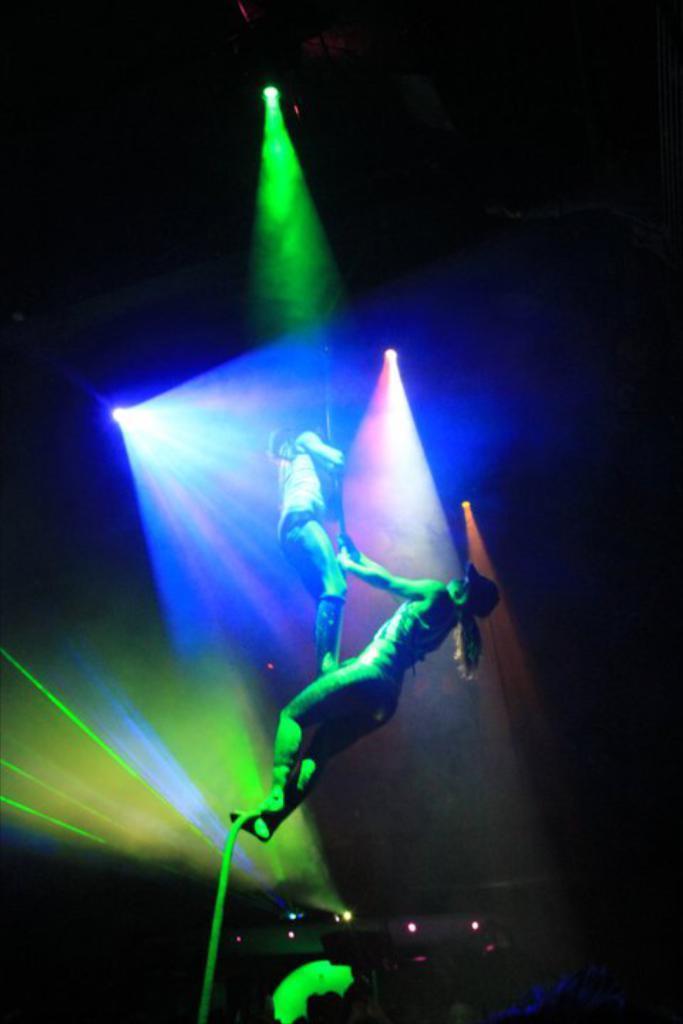How would you summarize this image in a sentence or two? This image is taken indoors. In this image the background is dark. In the middle of the image there are a few lights and two women are dancing and holding a pole. 